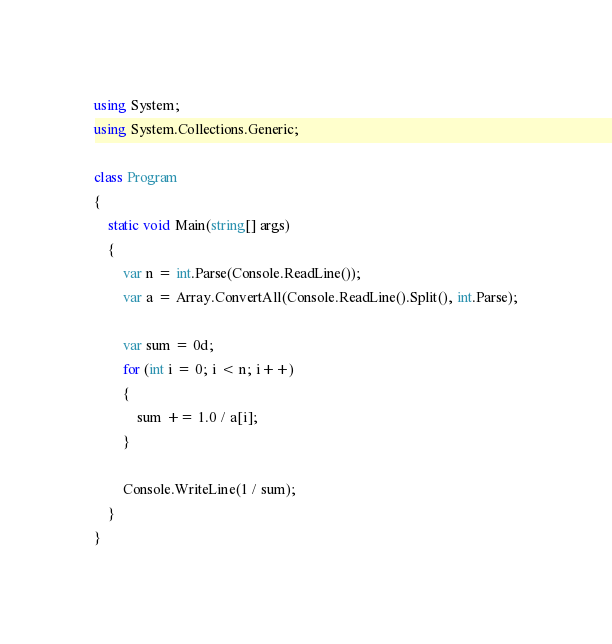<code> <loc_0><loc_0><loc_500><loc_500><_C#_>using System;
using System.Collections.Generic;

class Program
{
    static void Main(string[] args)
    {
        var n = int.Parse(Console.ReadLine());
        var a = Array.ConvertAll(Console.ReadLine().Split(), int.Parse);

        var sum = 0d;
        for (int i = 0; i < n; i++)
        {
            sum += 1.0 / a[i];
        }

        Console.WriteLine(1 / sum);
    }
}
</code> 